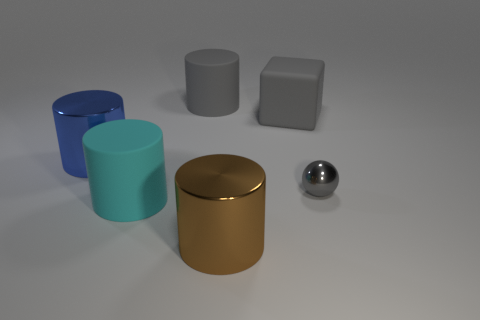If the objects had weights, which would you guess is the heaviest and why? If we were to guess based on size and assuming all objects are made of the same material, the large blue cylinder might be the heaviest due to its volume. However, if different materials are to be considered, the solid sphere could be the heaviest if it's solid throughout and made of a denser metal. 